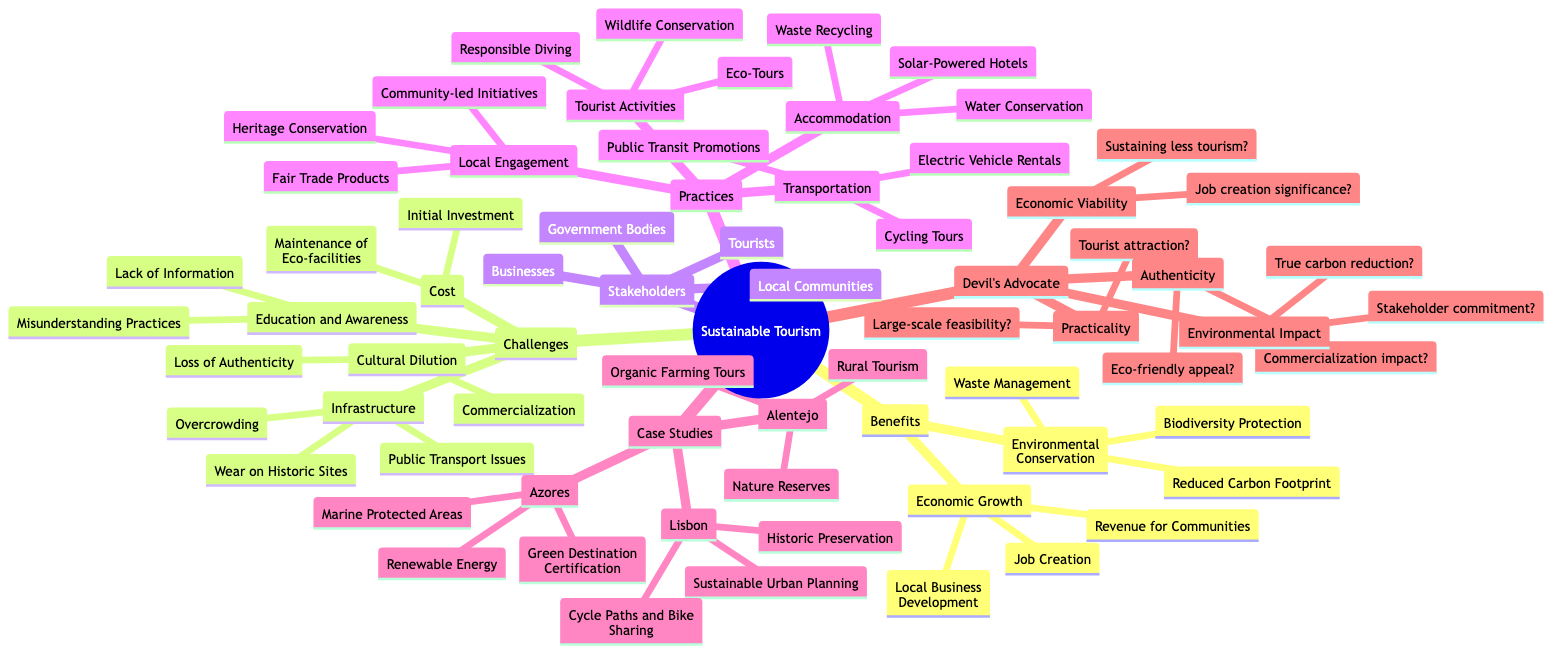What are two benefits of sustainable tourism listed in the diagram? The diagram mentions "Economic Growth" and "Environmental Conservation" under the "Benefits of Sustainable Tourism" node, indicating these are two key benefits.
Answer: Economic Growth, Environmental Conservation How many stakeholders are noted in the mind map? The "Stakeholders" section includes four groups: Government Bodies, Local Communities, Tourists, and Businesses, totaling four stakeholders.
Answer: 4 What are two challenges associated with sustainable tourism? The diagram identifies multiple challenges, including "Cost" and "Infrastructure," which are specifically mentioned under the "Challenges of Sustainable Tourism" node.
Answer: Cost, Infrastructure Which case study in Portugal includes marine protected areas? The "Azores" under the "Case Study in Portugal" section lists "Marine Protected Areas," indicating that this particular case study is focused on marine conservation efforts.
Answer: Azores What is one practice listed under accommodation for sustainable tourism? The diagram illustrates multiple options under "Accommodation," one of which is "Solar-Powered Hotels," denoting this as a specific sustainable practice.
Answer: Solar-Powered Hotels Does the diagram suggest that economic viability of sustainable tourism may raise questions? Under "The Devil’s Advocate Questions," the node clearly includes "Can the local economy sustain less tourism?" indicating concern about the economic viability of implementing sustainable tourism practices.
Answer: Yes What is one tourist activity promoting sustainability mentioned in the mind map? The section on "Tourist Activities" lists "Eco-Tours" as a particular activity promoting sustainable tourism, reflecting a focus on environmentally friendly practices.
Answer: Eco-Tours What are two categories of benefits depicted in the mind map? The diagram exhibits the "Benefits of Sustainable Tourism" segmented into "Economic Growth" and "Environmental Conservation," which categorize the benefits highlighted.
Answer: Economic Growth, Environmental Conservation Which group is responsible for local engagement in sustainable tourism practices? Under "Local Engagement," the diagram lists "Community-led Initiatives," establishing that local communities play a crucial role in fostering sustainable practices.
Answer: Community-led Initiatives 